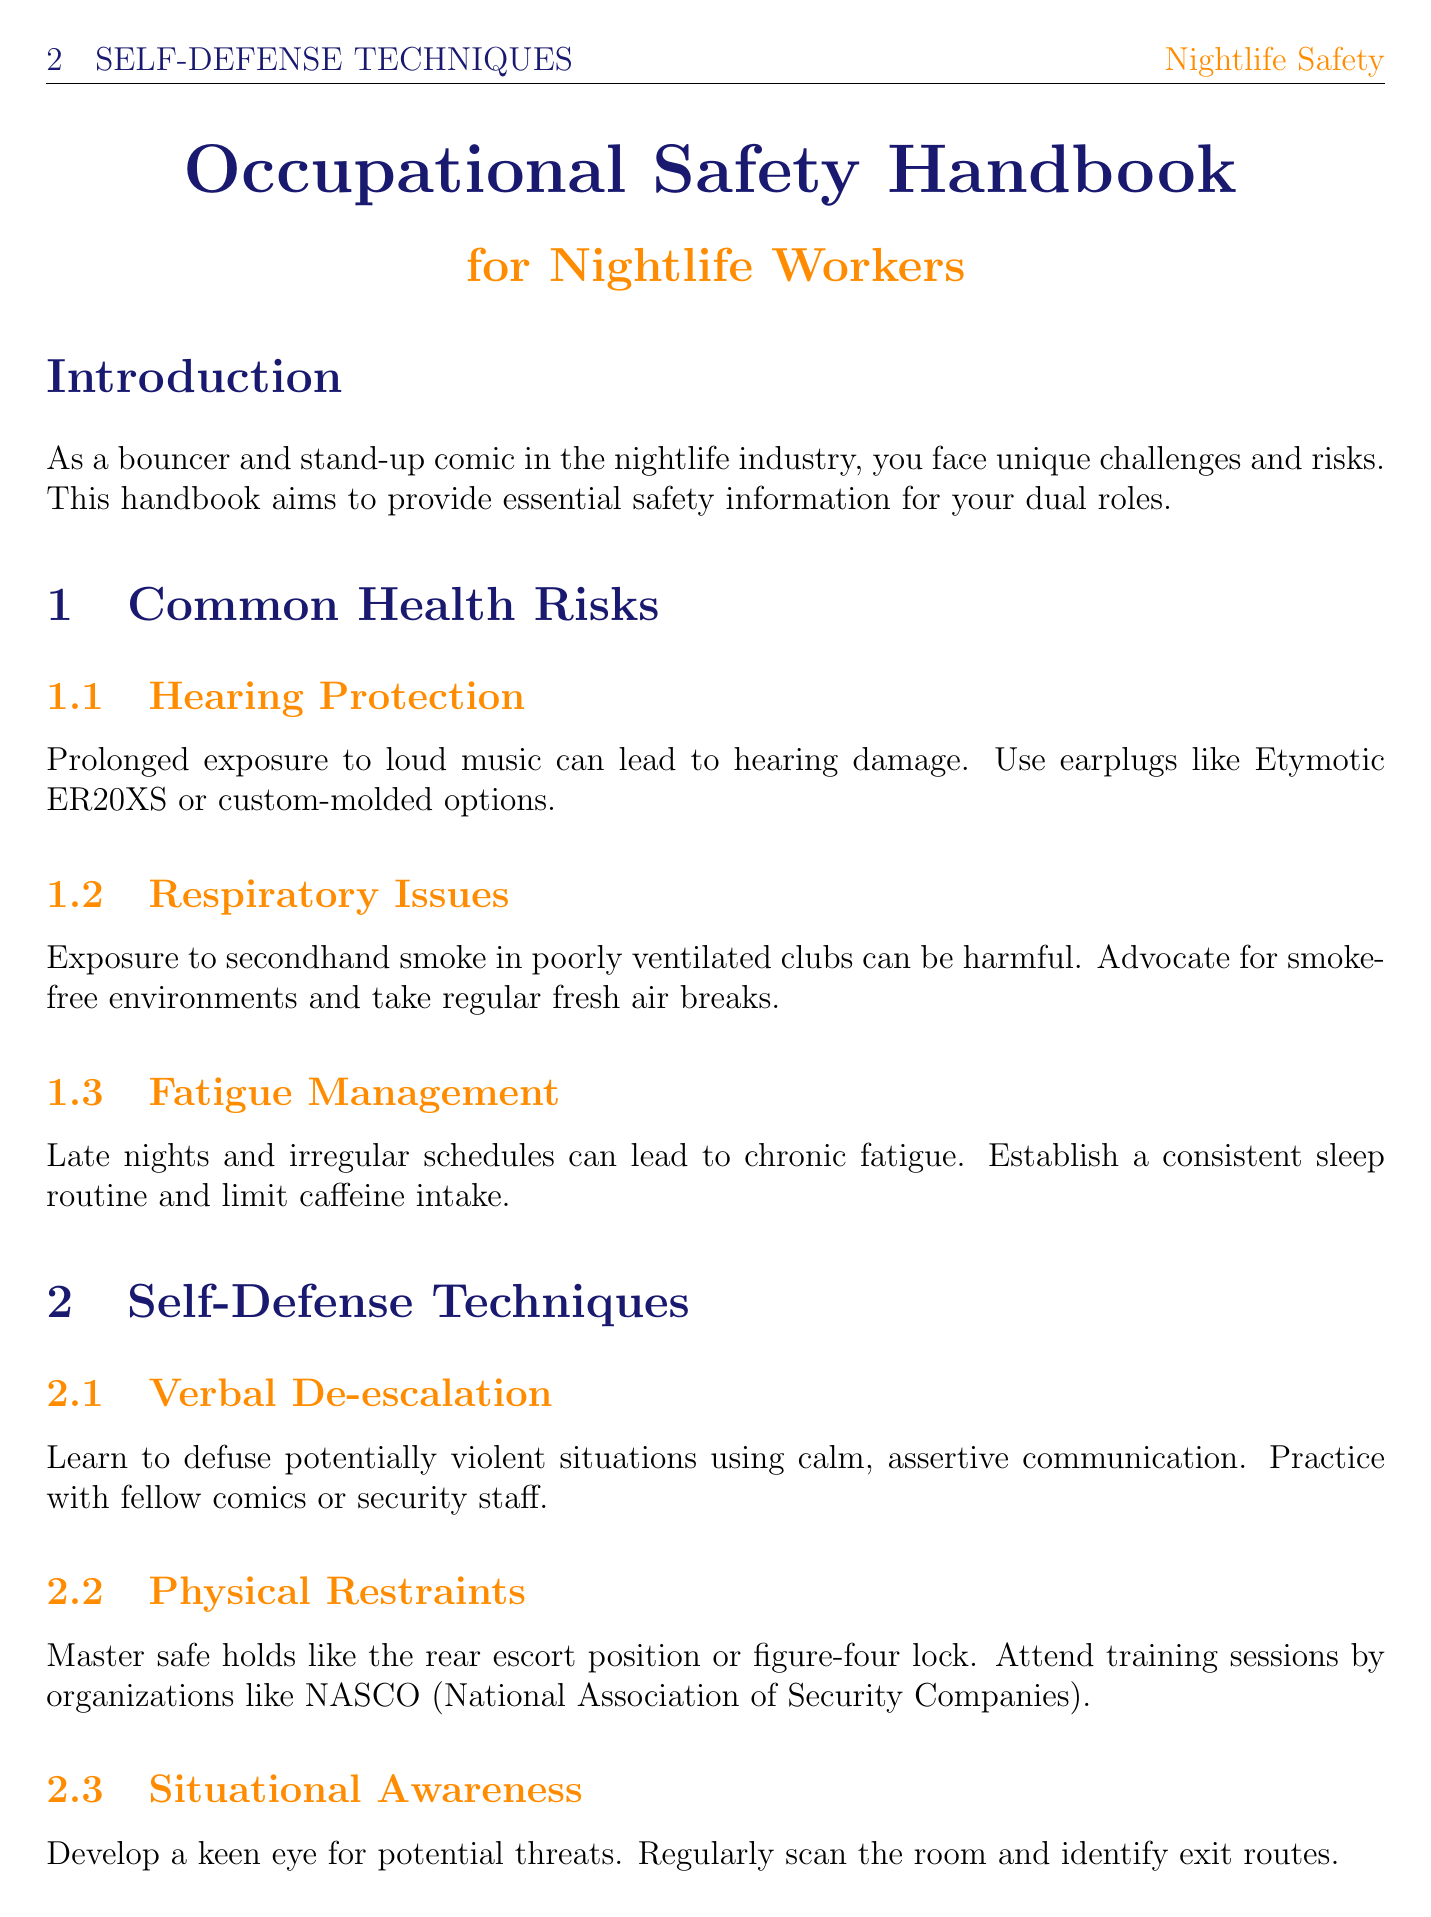what does the handbook aim to provide? The handbook aims to provide essential safety information for your dual roles.
Answer: essential safety information what should you use to protect your hearing? It is advised to use earplugs like Etymotic ER20XS or custom-molded options for hearing protection.
Answer: earplugs which organization offers training for physical restraints? The organization that offers training for physical restraints is NASCO.
Answer: NASCO what protocol should be followed in an active shooter situation? The protocol to follow in an active shooter situation is Run, Hide, Fight.
Answer: Run, Hide, Fight what type of clothing is recommended for bouncer shifts? The recommended type of clothing for bouncer shifts is steel-toed boots and kevlar-lined gloves.
Answer: steel-toed boots and kevlar-lined gloves how many subsections are there under Common Health Risks? There are three subsections under Common Health Risks.
Answer: three what technique can help manage stress? Mindfulness techniques can help manage stress.
Answer: mindfulness techniques which device is suggested for security communication? The suggested device for security communication is the Motorola CP200d.
Answer: Motorola CP200d what should you do during a fire emergency? You should assist in orderly evacuation and contact emergency services during a fire emergency.
Answer: assist in orderly evacuation and contact emergency services 